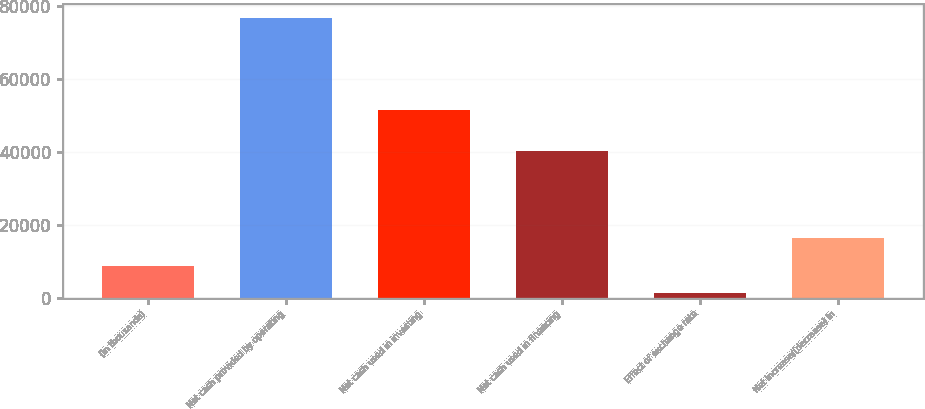<chart> <loc_0><loc_0><loc_500><loc_500><bar_chart><fcel>(in thousands)<fcel>Net cash provided by operating<fcel>Net cash used in investing<fcel>Net cash used in financing<fcel>Effect of exchange rate<fcel>Net increase/(decrease) in<nl><fcel>8677.6<fcel>76750<fcel>51387<fcel>40149<fcel>1114<fcel>16241.2<nl></chart> 